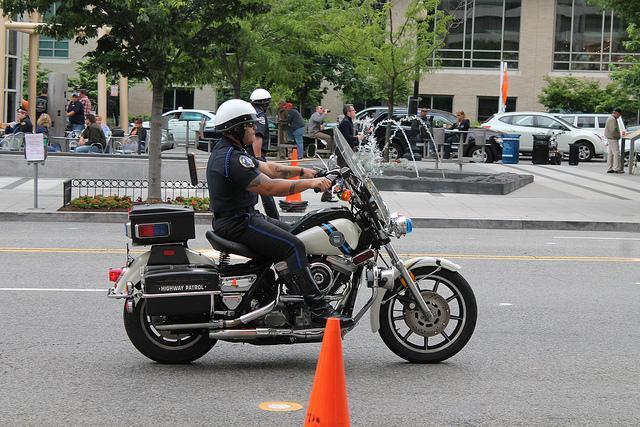How many people can you see?
Give a very brief answer. 2. How many cars can be seen?
Give a very brief answer. 2. How many boats are there?
Give a very brief answer. 0. 